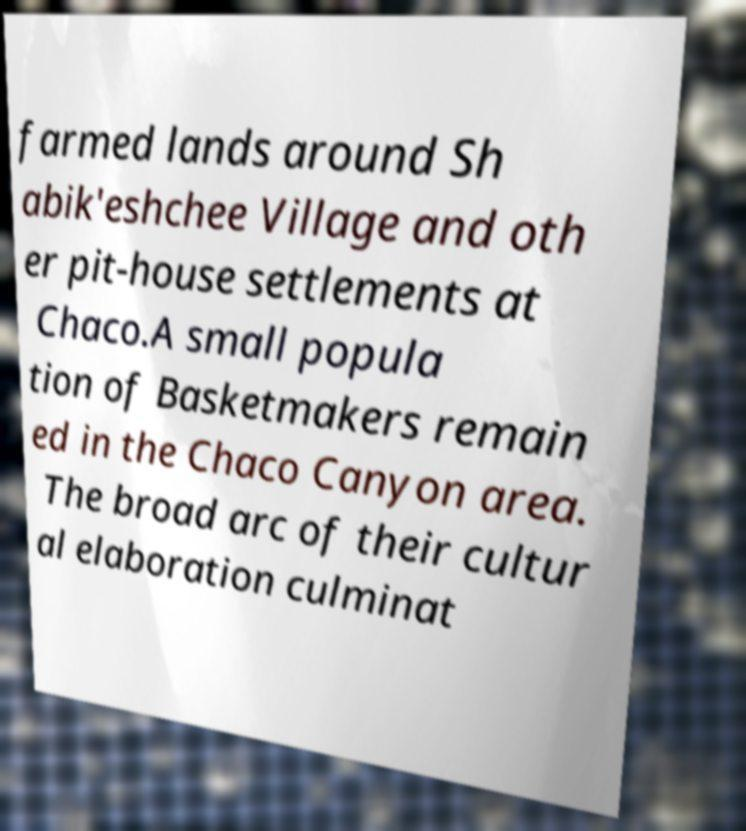Please read and relay the text visible in this image. What does it say? farmed lands around Sh abik'eshchee Village and oth er pit-house settlements at Chaco.A small popula tion of Basketmakers remain ed in the Chaco Canyon area. The broad arc of their cultur al elaboration culminat 